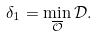<formula> <loc_0><loc_0><loc_500><loc_500>\delta _ { 1 } = \min _ { \overline { \mathcal { O } } } { \mathcal { D } } .</formula> 